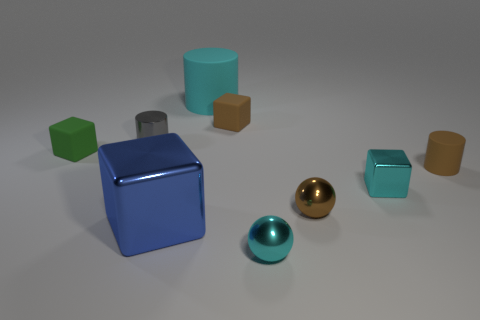Subtract all brown rubber cubes. How many cubes are left? 3 Subtract all gray cylinders. How many cylinders are left? 2 Subtract 2 spheres. How many spheres are left? 0 Subtract all small red balls. Subtract all blocks. How many objects are left? 5 Add 7 small brown blocks. How many small brown blocks are left? 8 Add 5 small cyan things. How many small cyan things exist? 7 Subtract 0 purple cylinders. How many objects are left? 9 Subtract all balls. How many objects are left? 7 Subtract all green spheres. Subtract all brown cylinders. How many spheres are left? 2 Subtract all blue balls. How many brown cylinders are left? 1 